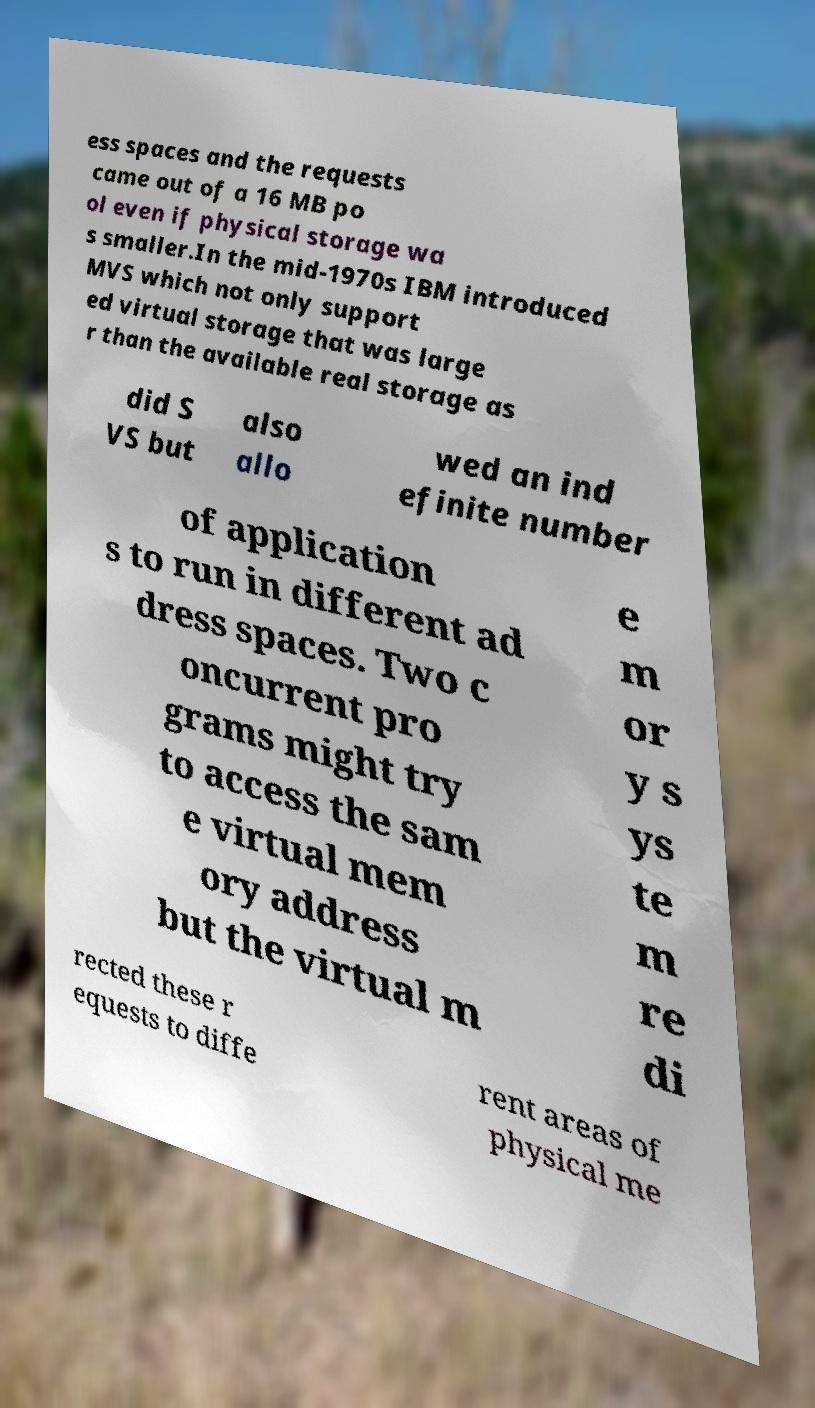For documentation purposes, I need the text within this image transcribed. Could you provide that? ess spaces and the requests came out of a 16 MB po ol even if physical storage wa s smaller.In the mid-1970s IBM introduced MVS which not only support ed virtual storage that was large r than the available real storage as did S VS but also allo wed an ind efinite number of application s to run in different ad dress spaces. Two c oncurrent pro grams might try to access the sam e virtual mem ory address but the virtual m e m or y s ys te m re di rected these r equests to diffe rent areas of physical me 